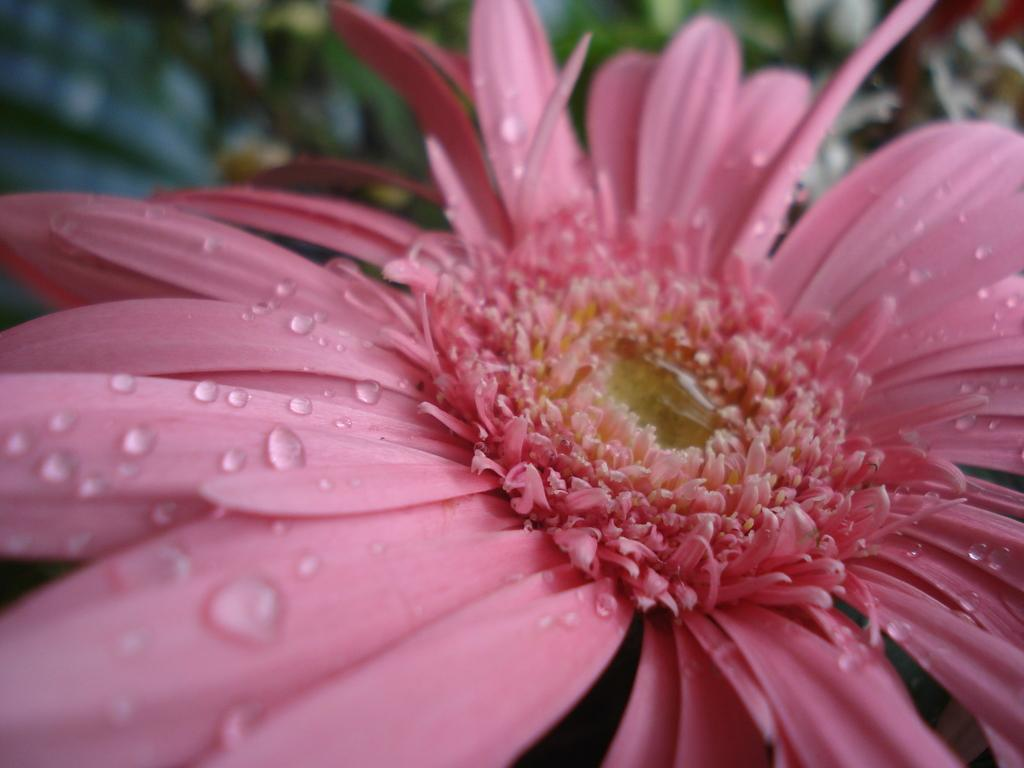What is the main subject of the picture? The main subject of the picture is a flower. Can you describe the flower in the picture? The flower has water droplets on it. What can be seen in the background of the picture? There are plants in the background of the picture, but they are not clearly visible. How many goldfish are swimming in the water droplets on the flower? There are no goldfish present in the image; it features a flower with water droplets. What type of sugar is sprinkled on the flower in the picture? There is no sugar present on the flower in the image. 